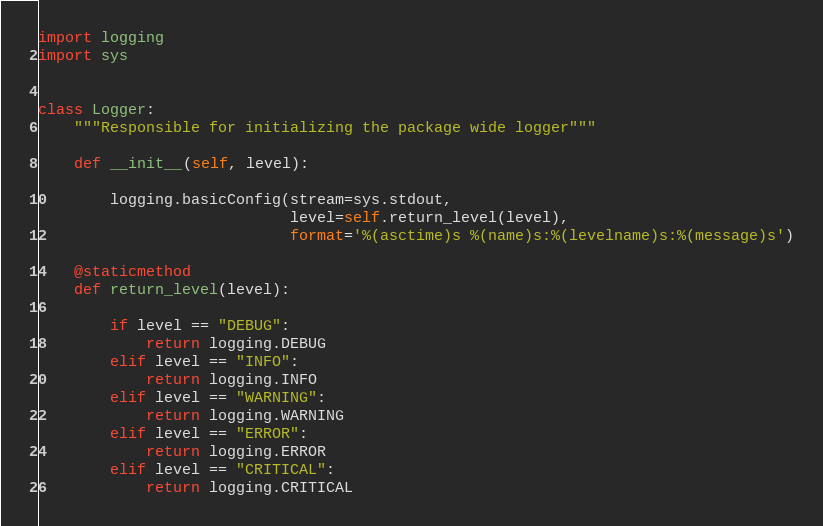<code> <loc_0><loc_0><loc_500><loc_500><_Python_>import logging
import sys


class Logger:
    """Responsible for initializing the package wide logger"""

    def __init__(self, level):

        logging.basicConfig(stream=sys.stdout,
                            level=self.return_level(level),
                            format='%(asctime)s %(name)s:%(levelname)s:%(message)s')

    @staticmethod
    def return_level(level):

        if level == "DEBUG":
            return logging.DEBUG
        elif level == "INFO":
            return logging.INFO
        elif level == "WARNING":
            return logging.WARNING
        elif level == "ERROR":
            return logging.ERROR
        elif level == "CRITICAL":
            return logging.CRITICAL
</code> 